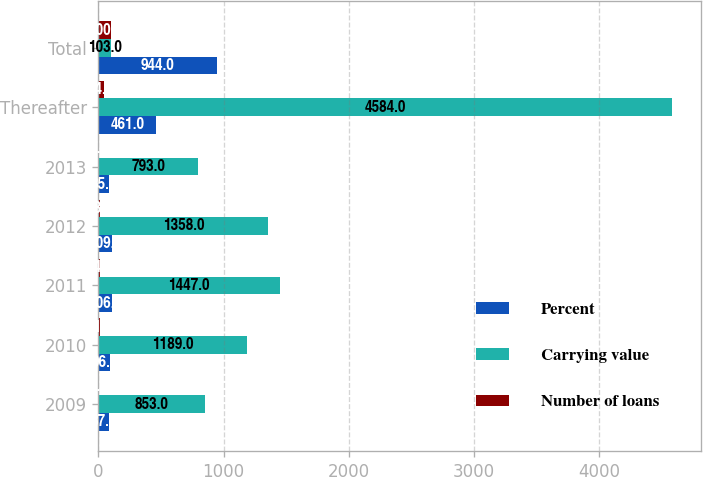Convert chart to OTSL. <chart><loc_0><loc_0><loc_500><loc_500><stacked_bar_chart><ecel><fcel>2009<fcel>2010<fcel>2011<fcel>2012<fcel>2013<fcel>Thereafter<fcel>Total<nl><fcel>Percent<fcel>87<fcel>96<fcel>106<fcel>109<fcel>85<fcel>461<fcel>944<nl><fcel>Carrying value<fcel>853<fcel>1189<fcel>1447<fcel>1358<fcel>793<fcel>4584<fcel>103<nl><fcel>Number of loans<fcel>8.3<fcel>11.6<fcel>14.2<fcel>13.3<fcel>7.8<fcel>44.8<fcel>100<nl></chart> 